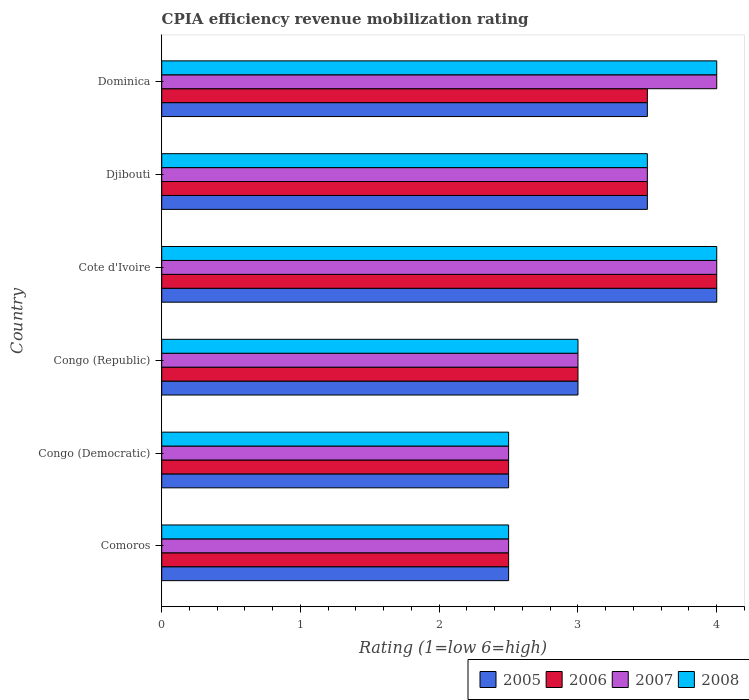How many different coloured bars are there?
Provide a succinct answer. 4. How many groups of bars are there?
Provide a succinct answer. 6. Are the number of bars per tick equal to the number of legend labels?
Ensure brevity in your answer.  Yes. Are the number of bars on each tick of the Y-axis equal?
Offer a terse response. Yes. How many bars are there on the 1st tick from the top?
Make the answer very short. 4. How many bars are there on the 1st tick from the bottom?
Give a very brief answer. 4. What is the label of the 5th group of bars from the top?
Your answer should be compact. Congo (Democratic). In how many cases, is the number of bars for a given country not equal to the number of legend labels?
Offer a terse response. 0. What is the CPIA rating in 2006 in Congo (Republic)?
Ensure brevity in your answer.  3. In which country was the CPIA rating in 2008 maximum?
Your answer should be compact. Cote d'Ivoire. In which country was the CPIA rating in 2005 minimum?
Make the answer very short. Comoros. What is the total CPIA rating in 2007 in the graph?
Provide a short and direct response. 19.5. What is the average CPIA rating in 2006 per country?
Your response must be concise. 3.17. What is the difference between the CPIA rating in 2005 and CPIA rating in 2006 in Congo (Democratic)?
Offer a very short reply. 0. In how many countries, is the CPIA rating in 2005 greater than the average CPIA rating in 2005 taken over all countries?
Provide a short and direct response. 3. Is it the case that in every country, the sum of the CPIA rating in 2007 and CPIA rating in 2006 is greater than the sum of CPIA rating in 2008 and CPIA rating in 2005?
Give a very brief answer. No. What does the 1st bar from the bottom in Dominica represents?
Your answer should be compact. 2005. How many bars are there?
Offer a terse response. 24. How many countries are there in the graph?
Your answer should be very brief. 6. Are the values on the major ticks of X-axis written in scientific E-notation?
Offer a very short reply. No. Does the graph contain any zero values?
Your answer should be very brief. No. Does the graph contain grids?
Give a very brief answer. No. Where does the legend appear in the graph?
Your answer should be very brief. Bottom right. How many legend labels are there?
Offer a very short reply. 4. How are the legend labels stacked?
Provide a succinct answer. Horizontal. What is the title of the graph?
Your answer should be compact. CPIA efficiency revenue mobilization rating. What is the label or title of the X-axis?
Offer a very short reply. Rating (1=low 6=high). What is the Rating (1=low 6=high) of 2005 in Comoros?
Offer a terse response. 2.5. What is the Rating (1=low 6=high) in 2007 in Comoros?
Keep it short and to the point. 2.5. What is the Rating (1=low 6=high) in 2008 in Comoros?
Ensure brevity in your answer.  2.5. What is the Rating (1=low 6=high) of 2007 in Congo (Democratic)?
Your answer should be very brief. 2.5. What is the Rating (1=low 6=high) of 2008 in Congo (Democratic)?
Provide a short and direct response. 2.5. What is the Rating (1=low 6=high) of 2005 in Congo (Republic)?
Offer a terse response. 3. What is the Rating (1=low 6=high) of 2006 in Congo (Republic)?
Your answer should be very brief. 3. What is the Rating (1=low 6=high) in 2007 in Congo (Republic)?
Your answer should be very brief. 3. What is the Rating (1=low 6=high) of 2008 in Congo (Republic)?
Your answer should be compact. 3. What is the Rating (1=low 6=high) in 2005 in Djibouti?
Offer a very short reply. 3.5. What is the Rating (1=low 6=high) of 2008 in Djibouti?
Offer a terse response. 3.5. What is the Rating (1=low 6=high) of 2005 in Dominica?
Keep it short and to the point. 3.5. What is the Rating (1=low 6=high) of 2006 in Dominica?
Provide a short and direct response. 3.5. Across all countries, what is the maximum Rating (1=low 6=high) of 2006?
Keep it short and to the point. 4. Across all countries, what is the maximum Rating (1=low 6=high) of 2007?
Give a very brief answer. 4. Across all countries, what is the maximum Rating (1=low 6=high) of 2008?
Make the answer very short. 4. Across all countries, what is the minimum Rating (1=low 6=high) in 2005?
Give a very brief answer. 2.5. Across all countries, what is the minimum Rating (1=low 6=high) of 2008?
Ensure brevity in your answer.  2.5. What is the total Rating (1=low 6=high) of 2005 in the graph?
Your answer should be compact. 19. What is the total Rating (1=low 6=high) of 2006 in the graph?
Offer a very short reply. 19. What is the difference between the Rating (1=low 6=high) in 2006 in Comoros and that in Congo (Democratic)?
Keep it short and to the point. 0. What is the difference between the Rating (1=low 6=high) of 2005 in Comoros and that in Congo (Republic)?
Keep it short and to the point. -0.5. What is the difference between the Rating (1=low 6=high) in 2006 in Comoros and that in Congo (Republic)?
Your response must be concise. -0.5. What is the difference between the Rating (1=low 6=high) of 2008 in Comoros and that in Congo (Republic)?
Provide a short and direct response. -0.5. What is the difference between the Rating (1=low 6=high) of 2005 in Comoros and that in Cote d'Ivoire?
Keep it short and to the point. -1.5. What is the difference between the Rating (1=low 6=high) in 2006 in Comoros and that in Cote d'Ivoire?
Ensure brevity in your answer.  -1.5. What is the difference between the Rating (1=low 6=high) of 2007 in Comoros and that in Cote d'Ivoire?
Make the answer very short. -1.5. What is the difference between the Rating (1=low 6=high) in 2008 in Comoros and that in Cote d'Ivoire?
Make the answer very short. -1.5. What is the difference between the Rating (1=low 6=high) of 2005 in Comoros and that in Djibouti?
Provide a short and direct response. -1. What is the difference between the Rating (1=low 6=high) in 2007 in Comoros and that in Djibouti?
Provide a short and direct response. -1. What is the difference between the Rating (1=low 6=high) of 2008 in Comoros and that in Djibouti?
Make the answer very short. -1. What is the difference between the Rating (1=low 6=high) of 2007 in Comoros and that in Dominica?
Keep it short and to the point. -1.5. What is the difference between the Rating (1=low 6=high) in 2008 in Comoros and that in Dominica?
Ensure brevity in your answer.  -1.5. What is the difference between the Rating (1=low 6=high) in 2006 in Congo (Democratic) and that in Congo (Republic)?
Your answer should be compact. -0.5. What is the difference between the Rating (1=low 6=high) in 2007 in Congo (Democratic) and that in Congo (Republic)?
Offer a very short reply. -0.5. What is the difference between the Rating (1=low 6=high) of 2005 in Congo (Democratic) and that in Cote d'Ivoire?
Provide a succinct answer. -1.5. What is the difference between the Rating (1=low 6=high) of 2006 in Congo (Democratic) and that in Cote d'Ivoire?
Give a very brief answer. -1.5. What is the difference between the Rating (1=low 6=high) of 2007 in Congo (Democratic) and that in Cote d'Ivoire?
Keep it short and to the point. -1.5. What is the difference between the Rating (1=low 6=high) of 2005 in Congo (Democratic) and that in Djibouti?
Offer a terse response. -1. What is the difference between the Rating (1=low 6=high) of 2006 in Congo (Democratic) and that in Djibouti?
Give a very brief answer. -1. What is the difference between the Rating (1=low 6=high) in 2007 in Congo (Democratic) and that in Djibouti?
Keep it short and to the point. -1. What is the difference between the Rating (1=low 6=high) of 2008 in Congo (Democratic) and that in Djibouti?
Your answer should be compact. -1. What is the difference between the Rating (1=low 6=high) in 2005 in Congo (Democratic) and that in Dominica?
Make the answer very short. -1. What is the difference between the Rating (1=low 6=high) of 2008 in Congo (Democratic) and that in Dominica?
Your answer should be very brief. -1.5. What is the difference between the Rating (1=low 6=high) of 2005 in Congo (Republic) and that in Cote d'Ivoire?
Make the answer very short. -1. What is the difference between the Rating (1=low 6=high) of 2005 in Congo (Republic) and that in Djibouti?
Provide a short and direct response. -0.5. What is the difference between the Rating (1=low 6=high) in 2008 in Congo (Republic) and that in Djibouti?
Your response must be concise. -0.5. What is the difference between the Rating (1=low 6=high) of 2005 in Congo (Republic) and that in Dominica?
Ensure brevity in your answer.  -0.5. What is the difference between the Rating (1=low 6=high) in 2006 in Congo (Republic) and that in Dominica?
Your answer should be compact. -0.5. What is the difference between the Rating (1=low 6=high) in 2007 in Congo (Republic) and that in Dominica?
Offer a very short reply. -1. What is the difference between the Rating (1=low 6=high) of 2006 in Cote d'Ivoire and that in Djibouti?
Your answer should be very brief. 0.5. What is the difference between the Rating (1=low 6=high) in 2007 in Cote d'Ivoire and that in Djibouti?
Provide a succinct answer. 0.5. What is the difference between the Rating (1=low 6=high) in 2008 in Cote d'Ivoire and that in Djibouti?
Your answer should be very brief. 0.5. What is the difference between the Rating (1=low 6=high) in 2006 in Cote d'Ivoire and that in Dominica?
Make the answer very short. 0.5. What is the difference between the Rating (1=low 6=high) of 2007 in Cote d'Ivoire and that in Dominica?
Ensure brevity in your answer.  0. What is the difference between the Rating (1=low 6=high) of 2008 in Cote d'Ivoire and that in Dominica?
Your answer should be compact. 0. What is the difference between the Rating (1=low 6=high) of 2007 in Djibouti and that in Dominica?
Give a very brief answer. -0.5. What is the difference between the Rating (1=low 6=high) of 2005 in Comoros and the Rating (1=low 6=high) of 2006 in Congo (Democratic)?
Ensure brevity in your answer.  0. What is the difference between the Rating (1=low 6=high) in 2005 in Comoros and the Rating (1=low 6=high) in 2007 in Congo (Democratic)?
Offer a very short reply. 0. What is the difference between the Rating (1=low 6=high) of 2006 in Comoros and the Rating (1=low 6=high) of 2008 in Congo (Democratic)?
Offer a very short reply. 0. What is the difference between the Rating (1=low 6=high) of 2007 in Comoros and the Rating (1=low 6=high) of 2008 in Congo (Democratic)?
Give a very brief answer. 0. What is the difference between the Rating (1=low 6=high) in 2005 in Comoros and the Rating (1=low 6=high) in 2006 in Congo (Republic)?
Provide a short and direct response. -0.5. What is the difference between the Rating (1=low 6=high) in 2005 in Comoros and the Rating (1=low 6=high) in 2007 in Congo (Republic)?
Offer a very short reply. -0.5. What is the difference between the Rating (1=low 6=high) in 2006 in Comoros and the Rating (1=low 6=high) in 2007 in Congo (Republic)?
Give a very brief answer. -0.5. What is the difference between the Rating (1=low 6=high) in 2006 in Comoros and the Rating (1=low 6=high) in 2008 in Congo (Republic)?
Ensure brevity in your answer.  -0.5. What is the difference between the Rating (1=low 6=high) in 2007 in Comoros and the Rating (1=low 6=high) in 2008 in Congo (Republic)?
Ensure brevity in your answer.  -0.5. What is the difference between the Rating (1=low 6=high) in 2005 in Comoros and the Rating (1=low 6=high) in 2006 in Cote d'Ivoire?
Provide a succinct answer. -1.5. What is the difference between the Rating (1=low 6=high) in 2006 in Comoros and the Rating (1=low 6=high) in 2008 in Cote d'Ivoire?
Your response must be concise. -1.5. What is the difference between the Rating (1=low 6=high) of 2007 in Comoros and the Rating (1=low 6=high) of 2008 in Cote d'Ivoire?
Provide a short and direct response. -1.5. What is the difference between the Rating (1=low 6=high) of 2005 in Comoros and the Rating (1=low 6=high) of 2008 in Djibouti?
Give a very brief answer. -1. What is the difference between the Rating (1=low 6=high) of 2006 in Comoros and the Rating (1=low 6=high) of 2008 in Djibouti?
Provide a succinct answer. -1. What is the difference between the Rating (1=low 6=high) of 2007 in Comoros and the Rating (1=low 6=high) of 2008 in Djibouti?
Your answer should be very brief. -1. What is the difference between the Rating (1=low 6=high) of 2005 in Comoros and the Rating (1=low 6=high) of 2008 in Dominica?
Keep it short and to the point. -1.5. What is the difference between the Rating (1=low 6=high) in 2006 in Congo (Democratic) and the Rating (1=low 6=high) in 2007 in Congo (Republic)?
Keep it short and to the point. -0.5. What is the difference between the Rating (1=low 6=high) of 2006 in Congo (Democratic) and the Rating (1=low 6=high) of 2008 in Congo (Republic)?
Ensure brevity in your answer.  -0.5. What is the difference between the Rating (1=low 6=high) of 2007 in Congo (Democratic) and the Rating (1=low 6=high) of 2008 in Congo (Republic)?
Your response must be concise. -0.5. What is the difference between the Rating (1=low 6=high) in 2005 in Congo (Democratic) and the Rating (1=low 6=high) in 2008 in Cote d'Ivoire?
Offer a very short reply. -1.5. What is the difference between the Rating (1=low 6=high) in 2006 in Congo (Democratic) and the Rating (1=low 6=high) in 2007 in Cote d'Ivoire?
Provide a succinct answer. -1.5. What is the difference between the Rating (1=low 6=high) of 2007 in Congo (Democratic) and the Rating (1=low 6=high) of 2008 in Cote d'Ivoire?
Offer a very short reply. -1.5. What is the difference between the Rating (1=low 6=high) in 2005 in Congo (Democratic) and the Rating (1=low 6=high) in 2006 in Djibouti?
Offer a very short reply. -1. What is the difference between the Rating (1=low 6=high) in 2005 in Congo (Democratic) and the Rating (1=low 6=high) in 2007 in Djibouti?
Ensure brevity in your answer.  -1. What is the difference between the Rating (1=low 6=high) of 2005 in Congo (Democratic) and the Rating (1=low 6=high) of 2008 in Djibouti?
Provide a succinct answer. -1. What is the difference between the Rating (1=low 6=high) of 2006 in Congo (Democratic) and the Rating (1=low 6=high) of 2007 in Djibouti?
Your answer should be very brief. -1. What is the difference between the Rating (1=low 6=high) of 2007 in Congo (Democratic) and the Rating (1=low 6=high) of 2008 in Djibouti?
Your answer should be very brief. -1. What is the difference between the Rating (1=low 6=high) of 2005 in Congo (Democratic) and the Rating (1=low 6=high) of 2007 in Dominica?
Provide a short and direct response. -1.5. What is the difference between the Rating (1=low 6=high) in 2005 in Congo (Democratic) and the Rating (1=low 6=high) in 2008 in Dominica?
Your answer should be very brief. -1.5. What is the difference between the Rating (1=low 6=high) in 2007 in Congo (Democratic) and the Rating (1=low 6=high) in 2008 in Dominica?
Offer a very short reply. -1.5. What is the difference between the Rating (1=low 6=high) of 2005 in Congo (Republic) and the Rating (1=low 6=high) of 2006 in Cote d'Ivoire?
Keep it short and to the point. -1. What is the difference between the Rating (1=low 6=high) in 2006 in Congo (Republic) and the Rating (1=low 6=high) in 2007 in Cote d'Ivoire?
Your answer should be very brief. -1. What is the difference between the Rating (1=low 6=high) of 2007 in Congo (Republic) and the Rating (1=low 6=high) of 2008 in Cote d'Ivoire?
Your response must be concise. -1. What is the difference between the Rating (1=low 6=high) in 2005 in Congo (Republic) and the Rating (1=low 6=high) in 2008 in Djibouti?
Give a very brief answer. -0.5. What is the difference between the Rating (1=low 6=high) of 2006 in Congo (Republic) and the Rating (1=low 6=high) of 2007 in Djibouti?
Keep it short and to the point. -0.5. What is the difference between the Rating (1=low 6=high) of 2007 in Congo (Republic) and the Rating (1=low 6=high) of 2008 in Djibouti?
Provide a short and direct response. -0.5. What is the difference between the Rating (1=low 6=high) of 2005 in Congo (Republic) and the Rating (1=low 6=high) of 2006 in Dominica?
Provide a short and direct response. -0.5. What is the difference between the Rating (1=low 6=high) in 2005 in Congo (Republic) and the Rating (1=low 6=high) in 2007 in Dominica?
Provide a short and direct response. -1. What is the difference between the Rating (1=low 6=high) in 2005 in Congo (Republic) and the Rating (1=low 6=high) in 2008 in Dominica?
Offer a very short reply. -1. What is the difference between the Rating (1=low 6=high) of 2006 in Congo (Republic) and the Rating (1=low 6=high) of 2008 in Dominica?
Make the answer very short. -1. What is the difference between the Rating (1=low 6=high) of 2007 in Congo (Republic) and the Rating (1=low 6=high) of 2008 in Dominica?
Make the answer very short. -1. What is the difference between the Rating (1=low 6=high) of 2005 in Cote d'Ivoire and the Rating (1=low 6=high) of 2007 in Djibouti?
Offer a very short reply. 0.5. What is the difference between the Rating (1=low 6=high) of 2006 in Cote d'Ivoire and the Rating (1=low 6=high) of 2007 in Djibouti?
Provide a short and direct response. 0.5. What is the difference between the Rating (1=low 6=high) of 2007 in Cote d'Ivoire and the Rating (1=low 6=high) of 2008 in Djibouti?
Provide a short and direct response. 0.5. What is the difference between the Rating (1=low 6=high) of 2005 in Cote d'Ivoire and the Rating (1=low 6=high) of 2006 in Dominica?
Make the answer very short. 0.5. What is the difference between the Rating (1=low 6=high) of 2005 in Cote d'Ivoire and the Rating (1=low 6=high) of 2007 in Dominica?
Your response must be concise. 0. What is the difference between the Rating (1=low 6=high) of 2005 in Cote d'Ivoire and the Rating (1=low 6=high) of 2008 in Dominica?
Your response must be concise. 0. What is the difference between the Rating (1=low 6=high) in 2006 in Cote d'Ivoire and the Rating (1=low 6=high) in 2008 in Dominica?
Ensure brevity in your answer.  0. What is the difference between the Rating (1=low 6=high) in 2005 in Djibouti and the Rating (1=low 6=high) in 2007 in Dominica?
Give a very brief answer. -0.5. What is the difference between the Rating (1=low 6=high) in 2006 in Djibouti and the Rating (1=low 6=high) in 2007 in Dominica?
Ensure brevity in your answer.  -0.5. What is the difference between the Rating (1=low 6=high) of 2006 in Djibouti and the Rating (1=low 6=high) of 2008 in Dominica?
Your response must be concise. -0.5. What is the difference between the Rating (1=low 6=high) in 2007 in Djibouti and the Rating (1=low 6=high) in 2008 in Dominica?
Offer a terse response. -0.5. What is the average Rating (1=low 6=high) in 2005 per country?
Keep it short and to the point. 3.17. What is the average Rating (1=low 6=high) in 2006 per country?
Your answer should be very brief. 3.17. What is the average Rating (1=low 6=high) in 2008 per country?
Provide a short and direct response. 3.25. What is the difference between the Rating (1=low 6=high) of 2005 and Rating (1=low 6=high) of 2006 in Comoros?
Make the answer very short. 0. What is the difference between the Rating (1=low 6=high) in 2005 and Rating (1=low 6=high) in 2007 in Comoros?
Your response must be concise. 0. What is the difference between the Rating (1=low 6=high) in 2005 and Rating (1=low 6=high) in 2008 in Comoros?
Offer a very short reply. 0. What is the difference between the Rating (1=low 6=high) in 2006 and Rating (1=low 6=high) in 2008 in Comoros?
Your response must be concise. 0. What is the difference between the Rating (1=low 6=high) of 2007 and Rating (1=low 6=high) of 2008 in Comoros?
Keep it short and to the point. 0. What is the difference between the Rating (1=low 6=high) of 2005 and Rating (1=low 6=high) of 2006 in Congo (Democratic)?
Provide a short and direct response. 0. What is the difference between the Rating (1=low 6=high) of 2005 and Rating (1=low 6=high) of 2007 in Congo (Democratic)?
Your response must be concise. 0. What is the difference between the Rating (1=low 6=high) of 2005 and Rating (1=low 6=high) of 2008 in Congo (Democratic)?
Offer a very short reply. 0. What is the difference between the Rating (1=low 6=high) in 2006 and Rating (1=low 6=high) in 2007 in Congo (Democratic)?
Your response must be concise. 0. What is the difference between the Rating (1=low 6=high) of 2007 and Rating (1=low 6=high) of 2008 in Congo (Democratic)?
Keep it short and to the point. 0. What is the difference between the Rating (1=low 6=high) of 2005 and Rating (1=low 6=high) of 2007 in Congo (Republic)?
Provide a short and direct response. 0. What is the difference between the Rating (1=low 6=high) in 2005 and Rating (1=low 6=high) in 2008 in Congo (Republic)?
Provide a succinct answer. 0. What is the difference between the Rating (1=low 6=high) of 2006 and Rating (1=low 6=high) of 2007 in Congo (Republic)?
Give a very brief answer. 0. What is the difference between the Rating (1=low 6=high) in 2007 and Rating (1=low 6=high) in 2008 in Congo (Republic)?
Keep it short and to the point. 0. What is the difference between the Rating (1=low 6=high) in 2005 and Rating (1=low 6=high) in 2007 in Cote d'Ivoire?
Ensure brevity in your answer.  0. What is the difference between the Rating (1=low 6=high) of 2005 and Rating (1=low 6=high) of 2008 in Cote d'Ivoire?
Your answer should be compact. 0. What is the difference between the Rating (1=low 6=high) of 2006 and Rating (1=low 6=high) of 2008 in Cote d'Ivoire?
Provide a short and direct response. 0. What is the difference between the Rating (1=low 6=high) of 2007 and Rating (1=low 6=high) of 2008 in Cote d'Ivoire?
Offer a very short reply. 0. What is the difference between the Rating (1=low 6=high) of 2005 and Rating (1=low 6=high) of 2007 in Djibouti?
Offer a terse response. 0. What is the difference between the Rating (1=low 6=high) of 2005 and Rating (1=low 6=high) of 2008 in Djibouti?
Your answer should be compact. 0. What is the difference between the Rating (1=low 6=high) in 2006 and Rating (1=low 6=high) in 2007 in Djibouti?
Keep it short and to the point. 0. What is the difference between the Rating (1=low 6=high) of 2007 and Rating (1=low 6=high) of 2008 in Djibouti?
Offer a very short reply. 0. What is the difference between the Rating (1=low 6=high) of 2005 and Rating (1=low 6=high) of 2006 in Dominica?
Keep it short and to the point. 0. What is the difference between the Rating (1=low 6=high) of 2005 and Rating (1=low 6=high) of 2007 in Dominica?
Make the answer very short. -0.5. What is the difference between the Rating (1=low 6=high) in 2007 and Rating (1=low 6=high) in 2008 in Dominica?
Make the answer very short. 0. What is the ratio of the Rating (1=low 6=high) of 2005 in Comoros to that in Congo (Democratic)?
Your answer should be compact. 1. What is the ratio of the Rating (1=low 6=high) of 2006 in Comoros to that in Congo (Democratic)?
Your response must be concise. 1. What is the ratio of the Rating (1=low 6=high) in 2007 in Comoros to that in Congo (Democratic)?
Ensure brevity in your answer.  1. What is the ratio of the Rating (1=low 6=high) of 2006 in Comoros to that in Congo (Republic)?
Give a very brief answer. 0.83. What is the ratio of the Rating (1=low 6=high) of 2008 in Comoros to that in Congo (Republic)?
Provide a succinct answer. 0.83. What is the ratio of the Rating (1=low 6=high) of 2006 in Comoros to that in Cote d'Ivoire?
Offer a very short reply. 0.62. What is the ratio of the Rating (1=low 6=high) in 2007 in Comoros to that in Cote d'Ivoire?
Offer a very short reply. 0.62. What is the ratio of the Rating (1=low 6=high) in 2005 in Comoros to that in Dominica?
Provide a short and direct response. 0.71. What is the ratio of the Rating (1=low 6=high) in 2007 in Comoros to that in Dominica?
Ensure brevity in your answer.  0.62. What is the ratio of the Rating (1=low 6=high) in 2008 in Comoros to that in Dominica?
Offer a terse response. 0.62. What is the ratio of the Rating (1=low 6=high) of 2008 in Congo (Democratic) to that in Congo (Republic)?
Your response must be concise. 0.83. What is the ratio of the Rating (1=low 6=high) of 2005 in Congo (Democratic) to that in Cote d'Ivoire?
Offer a very short reply. 0.62. What is the ratio of the Rating (1=low 6=high) of 2008 in Congo (Democratic) to that in Cote d'Ivoire?
Give a very brief answer. 0.62. What is the ratio of the Rating (1=low 6=high) of 2007 in Congo (Democratic) to that in Djibouti?
Your answer should be compact. 0.71. What is the ratio of the Rating (1=low 6=high) of 2005 in Congo (Democratic) to that in Dominica?
Provide a succinct answer. 0.71. What is the ratio of the Rating (1=low 6=high) of 2006 in Congo (Democratic) to that in Dominica?
Provide a succinct answer. 0.71. What is the ratio of the Rating (1=low 6=high) of 2008 in Congo (Democratic) to that in Dominica?
Keep it short and to the point. 0.62. What is the ratio of the Rating (1=low 6=high) of 2005 in Congo (Republic) to that in Djibouti?
Your response must be concise. 0.86. What is the ratio of the Rating (1=low 6=high) in 2007 in Congo (Republic) to that in Djibouti?
Your answer should be very brief. 0.86. What is the ratio of the Rating (1=low 6=high) in 2006 in Congo (Republic) to that in Dominica?
Keep it short and to the point. 0.86. What is the ratio of the Rating (1=low 6=high) of 2007 in Congo (Republic) to that in Dominica?
Ensure brevity in your answer.  0.75. What is the ratio of the Rating (1=low 6=high) in 2006 in Cote d'Ivoire to that in Djibouti?
Provide a short and direct response. 1.14. What is the ratio of the Rating (1=low 6=high) of 2005 in Cote d'Ivoire to that in Dominica?
Ensure brevity in your answer.  1.14. What is the ratio of the Rating (1=low 6=high) of 2007 in Cote d'Ivoire to that in Dominica?
Ensure brevity in your answer.  1. What is the ratio of the Rating (1=low 6=high) of 2008 in Cote d'Ivoire to that in Dominica?
Provide a succinct answer. 1. What is the difference between the highest and the second highest Rating (1=low 6=high) of 2007?
Your answer should be compact. 0. What is the difference between the highest and the lowest Rating (1=low 6=high) in 2007?
Ensure brevity in your answer.  1.5. 